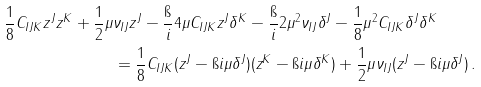Convert formula to latex. <formula><loc_0><loc_0><loc_500><loc_500>\frac { 1 } { 8 } C _ { I J K } z ^ { J } z ^ { K } + \frac { 1 } { 2 } \mu & \nu _ { I J } z ^ { J } - \frac { \i } { i } 4 \mu C _ { I J K } z ^ { J } \delta ^ { K } - \frac { \i } { i } 2 \mu ^ { 2 } \nu _ { I J } \delta ^ { J } - \frac { 1 } { 8 } \mu ^ { 2 } C _ { I J K } \delta ^ { J } \delta ^ { K } \\ & = \frac { 1 } { 8 } C _ { I J K } ( z ^ { J } - \i i \mu \delta ^ { J } ) ( z ^ { K } - \i i \mu \delta ^ { K } ) + \frac { 1 } { 2 } \mu \nu _ { I J } ( z ^ { J } - \i i \mu \delta ^ { J } ) \, .</formula> 